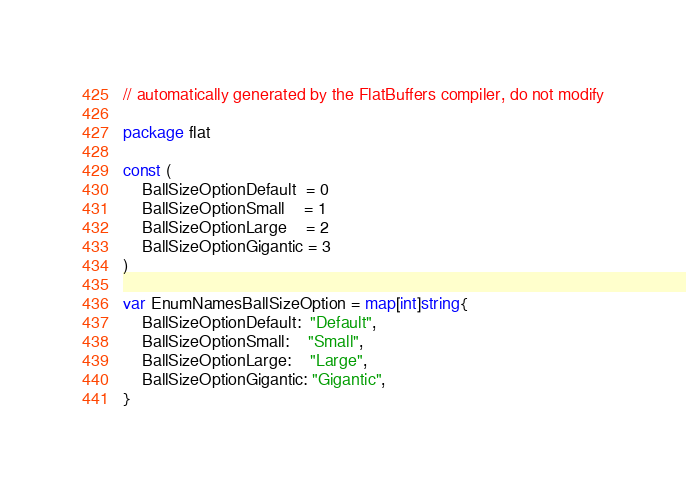Convert code to text. <code><loc_0><loc_0><loc_500><loc_500><_Go_>// automatically generated by the FlatBuffers compiler, do not modify

package flat

const (
	BallSizeOptionDefault  = 0
	BallSizeOptionSmall    = 1
	BallSizeOptionLarge    = 2
	BallSizeOptionGigantic = 3
)

var EnumNamesBallSizeOption = map[int]string{
	BallSizeOptionDefault:  "Default",
	BallSizeOptionSmall:    "Small",
	BallSizeOptionLarge:    "Large",
	BallSizeOptionGigantic: "Gigantic",
}
</code> 